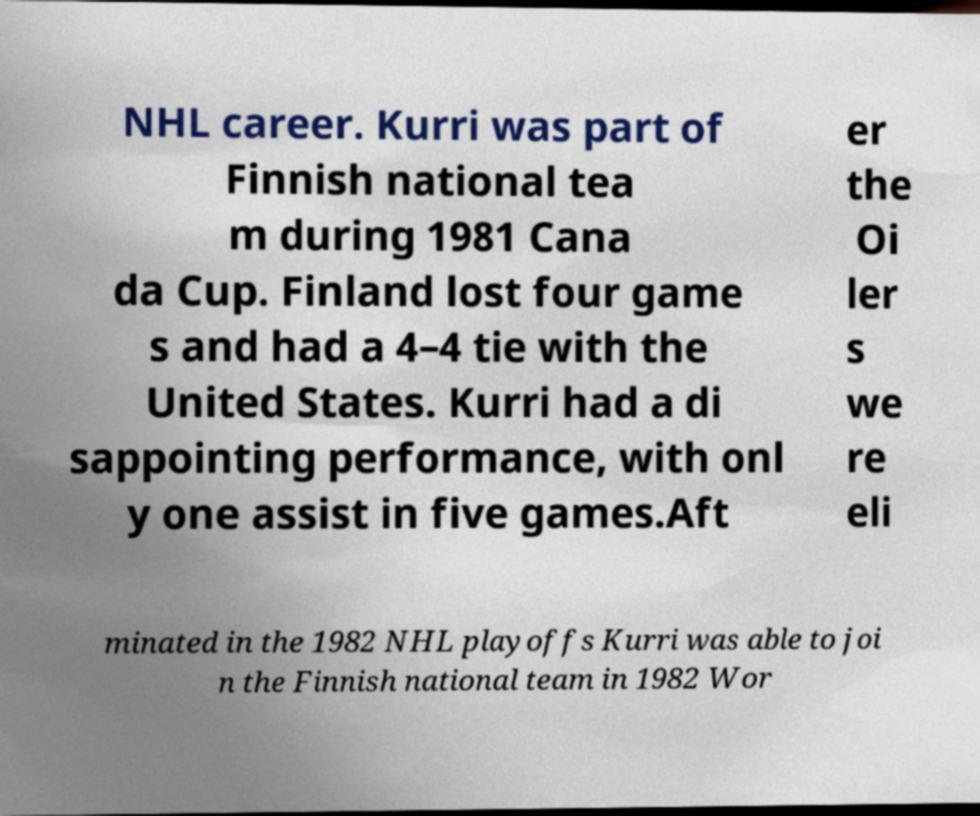Can you accurately transcribe the text from the provided image for me? NHL career. Kurri was part of Finnish national tea m during 1981 Cana da Cup. Finland lost four game s and had a 4–4 tie with the United States. Kurri had a di sappointing performance, with onl y one assist in five games.Aft er the Oi ler s we re eli minated in the 1982 NHL playoffs Kurri was able to joi n the Finnish national team in 1982 Wor 